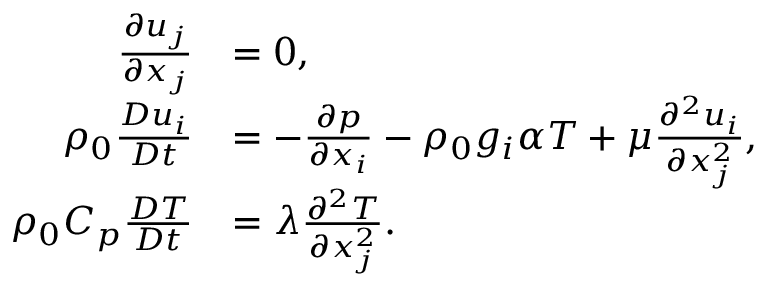Convert formula to latex. <formula><loc_0><loc_0><loc_500><loc_500>\begin{array} { r l } { \frac { \partial u _ { j } } { \partial x _ { j } } } & { = 0 , } \\ { \rho _ { 0 } \frac { D u _ { i } } { D t } } & { = - \frac { \partial p } { \partial x _ { i } } - \rho _ { 0 } g _ { i } \alpha T + \mu \frac { \partial ^ { 2 } u _ { i } } { \partial x _ { j } ^ { 2 } } , } \\ { \rho _ { 0 } C _ { p } \frac { D T } { D t } } & { = \lambda \frac { \partial ^ { 2 } T } { \partial x _ { j } ^ { 2 } } . } \end{array}</formula> 